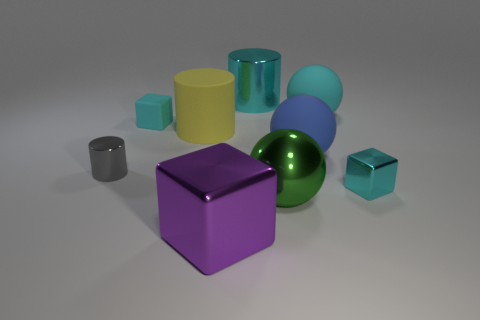Add 1 big green shiny balls. How many objects exist? 10 Subtract all cubes. How many objects are left? 6 Add 3 big green metallic spheres. How many big green metallic spheres exist? 4 Subtract 1 green spheres. How many objects are left? 8 Subtract all large yellow rubber things. Subtract all large matte objects. How many objects are left? 5 Add 1 big balls. How many big balls are left? 4 